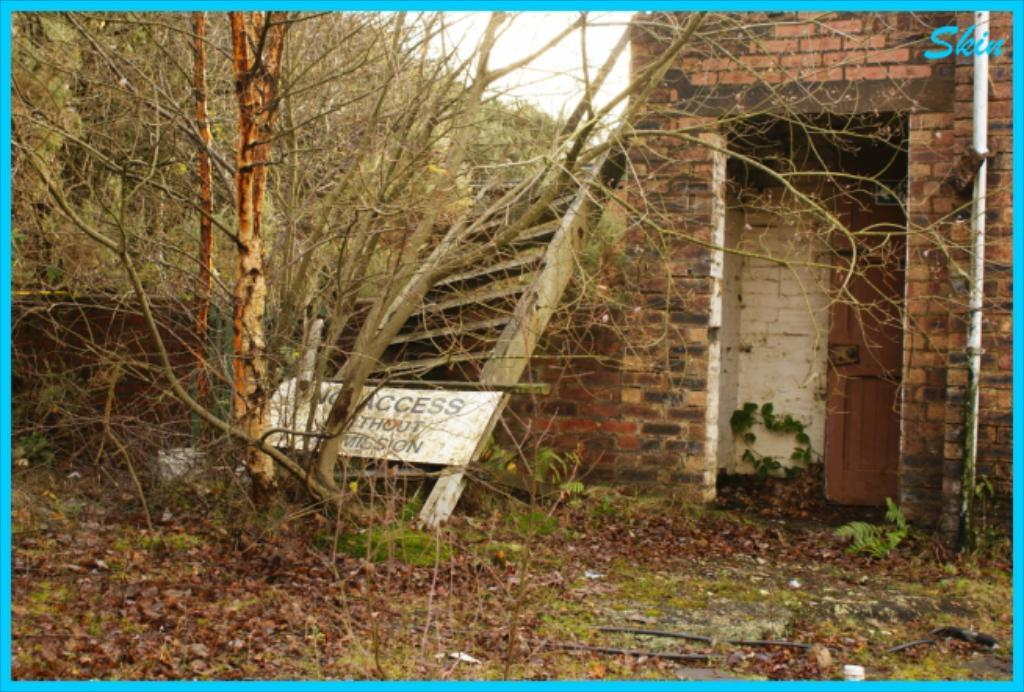<image>
Share a concise interpretation of the image provided. A sign with the words "No access" sits in front of an abandoned building. 